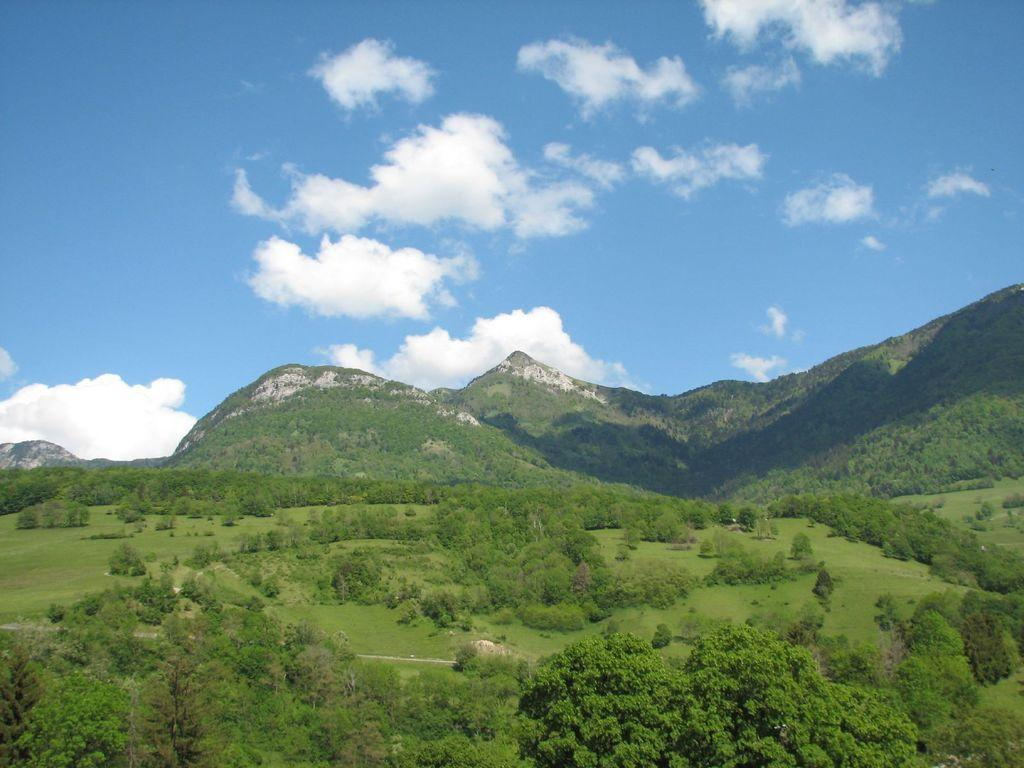What type of natural landscape can be seen in the image? There are hills in the image. What type of vegetation is present in the image? There are plants, trees, and grass visible in the image. What is visible in the sky in the image? The sky is visible in the image and has clouds. Where is the lift located in the image? There is no lift present in the image. What type of drum can be seen being played in the image? There is no drum present in the image. 